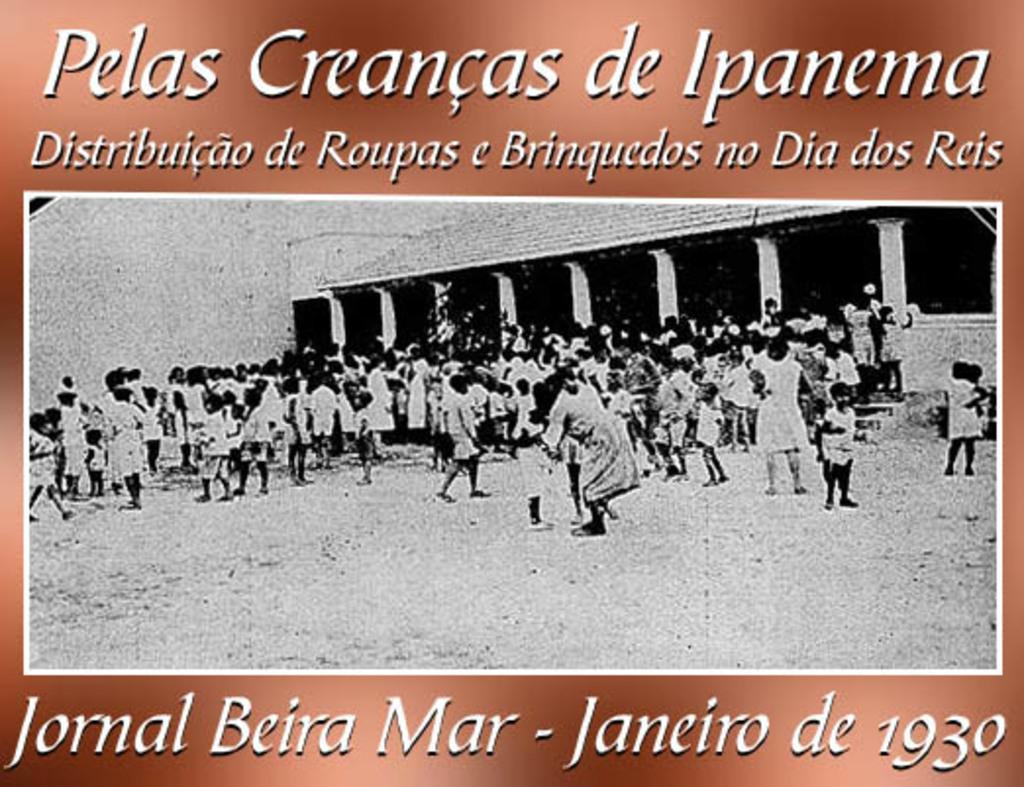What is the main subject of the poster in the image? The main subject of the poster in the image is a building. What features of the building can be seen on the poster? The building has a wall, a roof, and pillars. Are there any people depicted near the building on the poster? Yes, there are people standing near the building on the poster. Is there any text or writing on the poster? Yes, there is text or writing on the poster. What type of glue is being used by the people in the image? There are no people using glue in the image; the people are depicted on the poster near the building. What color are the trousers worn by the people in the image? There are no people wearing trousers in the image; the people are depicted on the poster near the building, and their clothing is not visible in detail. 